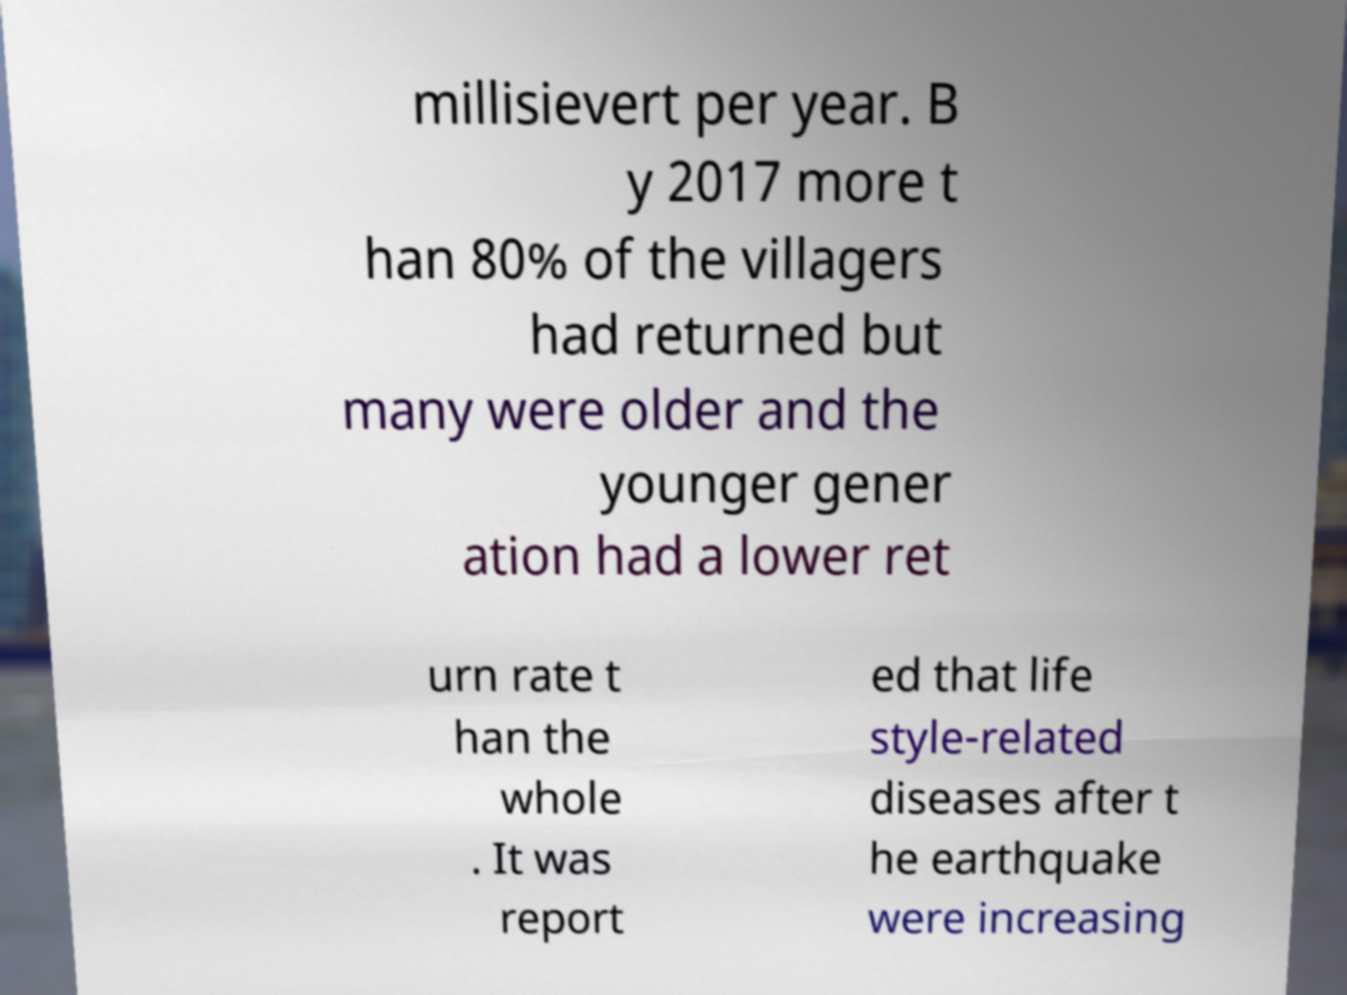I need the written content from this picture converted into text. Can you do that? millisievert per year. B y 2017 more t han 80% of the villagers had returned but many were older and the younger gener ation had a lower ret urn rate t han the whole . It was report ed that life style-related diseases after t he earthquake were increasing 